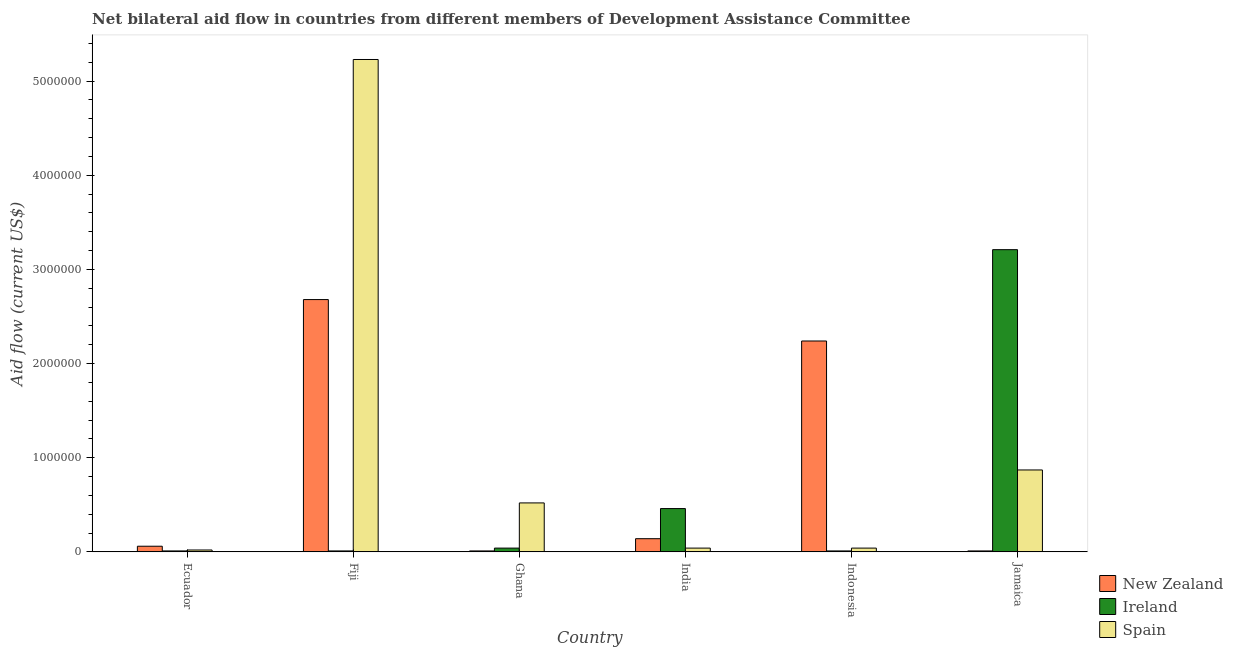How many different coloured bars are there?
Provide a short and direct response. 3. How many bars are there on the 3rd tick from the right?
Provide a succinct answer. 3. What is the label of the 3rd group of bars from the left?
Your response must be concise. Ghana. In how many cases, is the number of bars for a given country not equal to the number of legend labels?
Give a very brief answer. 0. What is the amount of aid provided by spain in Ghana?
Ensure brevity in your answer.  5.20e+05. Across all countries, what is the maximum amount of aid provided by ireland?
Provide a succinct answer. 3.21e+06. Across all countries, what is the minimum amount of aid provided by new zealand?
Your response must be concise. 10000. In which country was the amount of aid provided by spain maximum?
Your answer should be compact. Fiji. In which country was the amount of aid provided by ireland minimum?
Ensure brevity in your answer.  Ecuador. What is the total amount of aid provided by ireland in the graph?
Offer a terse response. 3.74e+06. What is the difference between the amount of aid provided by ireland in Fiji and that in India?
Provide a succinct answer. -4.50e+05. What is the difference between the amount of aid provided by ireland in Ecuador and the amount of aid provided by spain in Jamaica?
Provide a short and direct response. -8.60e+05. What is the average amount of aid provided by new zealand per country?
Give a very brief answer. 8.57e+05. What is the difference between the amount of aid provided by ireland and amount of aid provided by spain in Ghana?
Offer a very short reply. -4.80e+05. What is the ratio of the amount of aid provided by spain in Fiji to that in India?
Give a very brief answer. 130.75. What is the difference between the highest and the second highest amount of aid provided by ireland?
Give a very brief answer. 2.75e+06. What is the difference between the highest and the lowest amount of aid provided by ireland?
Your answer should be compact. 3.20e+06. In how many countries, is the amount of aid provided by spain greater than the average amount of aid provided by spain taken over all countries?
Ensure brevity in your answer.  1. Is the sum of the amount of aid provided by new zealand in Fiji and Ghana greater than the maximum amount of aid provided by spain across all countries?
Offer a very short reply. No. What does the 2nd bar from the left in Fiji represents?
Offer a terse response. Ireland. What does the 2nd bar from the right in India represents?
Your response must be concise. Ireland. How many bars are there?
Ensure brevity in your answer.  18. How many countries are there in the graph?
Your answer should be very brief. 6. What is the difference between two consecutive major ticks on the Y-axis?
Give a very brief answer. 1.00e+06. Are the values on the major ticks of Y-axis written in scientific E-notation?
Your answer should be very brief. No. Does the graph contain grids?
Give a very brief answer. No. How many legend labels are there?
Your response must be concise. 3. How are the legend labels stacked?
Ensure brevity in your answer.  Vertical. What is the title of the graph?
Offer a terse response. Net bilateral aid flow in countries from different members of Development Assistance Committee. What is the Aid flow (current US$) in New Zealand in Ecuador?
Offer a terse response. 6.00e+04. What is the Aid flow (current US$) in Spain in Ecuador?
Make the answer very short. 2.00e+04. What is the Aid flow (current US$) of New Zealand in Fiji?
Your response must be concise. 2.68e+06. What is the Aid flow (current US$) of Spain in Fiji?
Provide a short and direct response. 5.23e+06. What is the Aid flow (current US$) of New Zealand in Ghana?
Make the answer very short. 10000. What is the Aid flow (current US$) in Spain in Ghana?
Offer a terse response. 5.20e+05. What is the Aid flow (current US$) of Ireland in India?
Provide a succinct answer. 4.60e+05. What is the Aid flow (current US$) of Spain in India?
Give a very brief answer. 4.00e+04. What is the Aid flow (current US$) of New Zealand in Indonesia?
Give a very brief answer. 2.24e+06. What is the Aid flow (current US$) of Ireland in Indonesia?
Provide a succinct answer. 10000. What is the Aid flow (current US$) of Ireland in Jamaica?
Offer a terse response. 3.21e+06. What is the Aid flow (current US$) in Spain in Jamaica?
Your answer should be very brief. 8.70e+05. Across all countries, what is the maximum Aid flow (current US$) of New Zealand?
Keep it short and to the point. 2.68e+06. Across all countries, what is the maximum Aid flow (current US$) of Ireland?
Give a very brief answer. 3.21e+06. Across all countries, what is the maximum Aid flow (current US$) in Spain?
Your response must be concise. 5.23e+06. What is the total Aid flow (current US$) of New Zealand in the graph?
Make the answer very short. 5.14e+06. What is the total Aid flow (current US$) in Ireland in the graph?
Offer a terse response. 3.74e+06. What is the total Aid flow (current US$) in Spain in the graph?
Offer a terse response. 6.72e+06. What is the difference between the Aid flow (current US$) of New Zealand in Ecuador and that in Fiji?
Your response must be concise. -2.62e+06. What is the difference between the Aid flow (current US$) of Ireland in Ecuador and that in Fiji?
Keep it short and to the point. 0. What is the difference between the Aid flow (current US$) of Spain in Ecuador and that in Fiji?
Your response must be concise. -5.21e+06. What is the difference between the Aid flow (current US$) in Ireland in Ecuador and that in Ghana?
Your answer should be very brief. -3.00e+04. What is the difference between the Aid flow (current US$) in Spain in Ecuador and that in Ghana?
Your response must be concise. -5.00e+05. What is the difference between the Aid flow (current US$) in Ireland in Ecuador and that in India?
Ensure brevity in your answer.  -4.50e+05. What is the difference between the Aid flow (current US$) in New Zealand in Ecuador and that in Indonesia?
Your answer should be very brief. -2.18e+06. What is the difference between the Aid flow (current US$) of Spain in Ecuador and that in Indonesia?
Your answer should be compact. -2.00e+04. What is the difference between the Aid flow (current US$) of New Zealand in Ecuador and that in Jamaica?
Your response must be concise. 5.00e+04. What is the difference between the Aid flow (current US$) in Ireland in Ecuador and that in Jamaica?
Your answer should be very brief. -3.20e+06. What is the difference between the Aid flow (current US$) in Spain in Ecuador and that in Jamaica?
Provide a short and direct response. -8.50e+05. What is the difference between the Aid flow (current US$) of New Zealand in Fiji and that in Ghana?
Provide a short and direct response. 2.67e+06. What is the difference between the Aid flow (current US$) of Ireland in Fiji and that in Ghana?
Keep it short and to the point. -3.00e+04. What is the difference between the Aid flow (current US$) in Spain in Fiji and that in Ghana?
Your answer should be compact. 4.71e+06. What is the difference between the Aid flow (current US$) of New Zealand in Fiji and that in India?
Make the answer very short. 2.54e+06. What is the difference between the Aid flow (current US$) in Ireland in Fiji and that in India?
Offer a terse response. -4.50e+05. What is the difference between the Aid flow (current US$) of Spain in Fiji and that in India?
Your answer should be very brief. 5.19e+06. What is the difference between the Aid flow (current US$) in New Zealand in Fiji and that in Indonesia?
Provide a short and direct response. 4.40e+05. What is the difference between the Aid flow (current US$) in Ireland in Fiji and that in Indonesia?
Your answer should be very brief. 0. What is the difference between the Aid flow (current US$) of Spain in Fiji and that in Indonesia?
Make the answer very short. 5.19e+06. What is the difference between the Aid flow (current US$) of New Zealand in Fiji and that in Jamaica?
Offer a terse response. 2.67e+06. What is the difference between the Aid flow (current US$) in Ireland in Fiji and that in Jamaica?
Ensure brevity in your answer.  -3.20e+06. What is the difference between the Aid flow (current US$) of Spain in Fiji and that in Jamaica?
Keep it short and to the point. 4.36e+06. What is the difference between the Aid flow (current US$) of Ireland in Ghana and that in India?
Your response must be concise. -4.20e+05. What is the difference between the Aid flow (current US$) in Spain in Ghana and that in India?
Make the answer very short. 4.80e+05. What is the difference between the Aid flow (current US$) in New Zealand in Ghana and that in Indonesia?
Offer a terse response. -2.23e+06. What is the difference between the Aid flow (current US$) in Ireland in Ghana and that in Indonesia?
Your answer should be compact. 3.00e+04. What is the difference between the Aid flow (current US$) in New Zealand in Ghana and that in Jamaica?
Offer a terse response. 0. What is the difference between the Aid flow (current US$) of Ireland in Ghana and that in Jamaica?
Ensure brevity in your answer.  -3.17e+06. What is the difference between the Aid flow (current US$) in Spain in Ghana and that in Jamaica?
Provide a succinct answer. -3.50e+05. What is the difference between the Aid flow (current US$) in New Zealand in India and that in Indonesia?
Provide a succinct answer. -2.10e+06. What is the difference between the Aid flow (current US$) in New Zealand in India and that in Jamaica?
Keep it short and to the point. 1.30e+05. What is the difference between the Aid flow (current US$) in Ireland in India and that in Jamaica?
Make the answer very short. -2.75e+06. What is the difference between the Aid flow (current US$) in Spain in India and that in Jamaica?
Keep it short and to the point. -8.30e+05. What is the difference between the Aid flow (current US$) in New Zealand in Indonesia and that in Jamaica?
Your answer should be very brief. 2.23e+06. What is the difference between the Aid flow (current US$) in Ireland in Indonesia and that in Jamaica?
Your response must be concise. -3.20e+06. What is the difference between the Aid flow (current US$) in Spain in Indonesia and that in Jamaica?
Offer a very short reply. -8.30e+05. What is the difference between the Aid flow (current US$) in New Zealand in Ecuador and the Aid flow (current US$) in Spain in Fiji?
Offer a terse response. -5.17e+06. What is the difference between the Aid flow (current US$) in Ireland in Ecuador and the Aid flow (current US$) in Spain in Fiji?
Give a very brief answer. -5.22e+06. What is the difference between the Aid flow (current US$) of New Zealand in Ecuador and the Aid flow (current US$) of Spain in Ghana?
Provide a succinct answer. -4.60e+05. What is the difference between the Aid flow (current US$) in Ireland in Ecuador and the Aid flow (current US$) in Spain in Ghana?
Give a very brief answer. -5.10e+05. What is the difference between the Aid flow (current US$) in New Zealand in Ecuador and the Aid flow (current US$) in Ireland in India?
Give a very brief answer. -4.00e+05. What is the difference between the Aid flow (current US$) in New Zealand in Ecuador and the Aid flow (current US$) in Spain in India?
Your answer should be compact. 2.00e+04. What is the difference between the Aid flow (current US$) of New Zealand in Ecuador and the Aid flow (current US$) of Spain in Indonesia?
Your answer should be compact. 2.00e+04. What is the difference between the Aid flow (current US$) of New Zealand in Ecuador and the Aid flow (current US$) of Ireland in Jamaica?
Your answer should be compact. -3.15e+06. What is the difference between the Aid flow (current US$) in New Zealand in Ecuador and the Aid flow (current US$) in Spain in Jamaica?
Make the answer very short. -8.10e+05. What is the difference between the Aid flow (current US$) of Ireland in Ecuador and the Aid flow (current US$) of Spain in Jamaica?
Give a very brief answer. -8.60e+05. What is the difference between the Aid flow (current US$) of New Zealand in Fiji and the Aid flow (current US$) of Ireland in Ghana?
Offer a terse response. 2.64e+06. What is the difference between the Aid flow (current US$) in New Zealand in Fiji and the Aid flow (current US$) in Spain in Ghana?
Provide a short and direct response. 2.16e+06. What is the difference between the Aid flow (current US$) of Ireland in Fiji and the Aid flow (current US$) of Spain in Ghana?
Offer a very short reply. -5.10e+05. What is the difference between the Aid flow (current US$) of New Zealand in Fiji and the Aid flow (current US$) of Ireland in India?
Keep it short and to the point. 2.22e+06. What is the difference between the Aid flow (current US$) of New Zealand in Fiji and the Aid flow (current US$) of Spain in India?
Your answer should be compact. 2.64e+06. What is the difference between the Aid flow (current US$) of Ireland in Fiji and the Aid flow (current US$) of Spain in India?
Your response must be concise. -3.00e+04. What is the difference between the Aid flow (current US$) in New Zealand in Fiji and the Aid flow (current US$) in Ireland in Indonesia?
Give a very brief answer. 2.67e+06. What is the difference between the Aid flow (current US$) of New Zealand in Fiji and the Aid flow (current US$) of Spain in Indonesia?
Provide a succinct answer. 2.64e+06. What is the difference between the Aid flow (current US$) in New Zealand in Fiji and the Aid flow (current US$) in Ireland in Jamaica?
Your response must be concise. -5.30e+05. What is the difference between the Aid flow (current US$) in New Zealand in Fiji and the Aid flow (current US$) in Spain in Jamaica?
Offer a very short reply. 1.81e+06. What is the difference between the Aid flow (current US$) in Ireland in Fiji and the Aid flow (current US$) in Spain in Jamaica?
Your response must be concise. -8.60e+05. What is the difference between the Aid flow (current US$) of New Zealand in Ghana and the Aid flow (current US$) of Ireland in India?
Offer a terse response. -4.50e+05. What is the difference between the Aid flow (current US$) of New Zealand in Ghana and the Aid flow (current US$) of Ireland in Indonesia?
Provide a short and direct response. 0. What is the difference between the Aid flow (current US$) of Ireland in Ghana and the Aid flow (current US$) of Spain in Indonesia?
Provide a short and direct response. 0. What is the difference between the Aid flow (current US$) of New Zealand in Ghana and the Aid flow (current US$) of Ireland in Jamaica?
Provide a short and direct response. -3.20e+06. What is the difference between the Aid flow (current US$) in New Zealand in Ghana and the Aid flow (current US$) in Spain in Jamaica?
Provide a short and direct response. -8.60e+05. What is the difference between the Aid flow (current US$) of Ireland in Ghana and the Aid flow (current US$) of Spain in Jamaica?
Provide a succinct answer. -8.30e+05. What is the difference between the Aid flow (current US$) of Ireland in India and the Aid flow (current US$) of Spain in Indonesia?
Ensure brevity in your answer.  4.20e+05. What is the difference between the Aid flow (current US$) in New Zealand in India and the Aid flow (current US$) in Ireland in Jamaica?
Your answer should be compact. -3.07e+06. What is the difference between the Aid flow (current US$) in New Zealand in India and the Aid flow (current US$) in Spain in Jamaica?
Offer a very short reply. -7.30e+05. What is the difference between the Aid flow (current US$) in Ireland in India and the Aid flow (current US$) in Spain in Jamaica?
Offer a very short reply. -4.10e+05. What is the difference between the Aid flow (current US$) of New Zealand in Indonesia and the Aid flow (current US$) of Ireland in Jamaica?
Make the answer very short. -9.70e+05. What is the difference between the Aid flow (current US$) of New Zealand in Indonesia and the Aid flow (current US$) of Spain in Jamaica?
Your response must be concise. 1.37e+06. What is the difference between the Aid flow (current US$) in Ireland in Indonesia and the Aid flow (current US$) in Spain in Jamaica?
Make the answer very short. -8.60e+05. What is the average Aid flow (current US$) of New Zealand per country?
Offer a very short reply. 8.57e+05. What is the average Aid flow (current US$) in Ireland per country?
Offer a terse response. 6.23e+05. What is the average Aid flow (current US$) of Spain per country?
Your response must be concise. 1.12e+06. What is the difference between the Aid flow (current US$) of New Zealand and Aid flow (current US$) of Ireland in Ecuador?
Offer a very short reply. 5.00e+04. What is the difference between the Aid flow (current US$) in New Zealand and Aid flow (current US$) in Spain in Ecuador?
Your response must be concise. 4.00e+04. What is the difference between the Aid flow (current US$) in Ireland and Aid flow (current US$) in Spain in Ecuador?
Offer a terse response. -10000. What is the difference between the Aid flow (current US$) in New Zealand and Aid flow (current US$) in Ireland in Fiji?
Your answer should be very brief. 2.67e+06. What is the difference between the Aid flow (current US$) in New Zealand and Aid flow (current US$) in Spain in Fiji?
Your answer should be compact. -2.55e+06. What is the difference between the Aid flow (current US$) of Ireland and Aid flow (current US$) of Spain in Fiji?
Give a very brief answer. -5.22e+06. What is the difference between the Aid flow (current US$) of New Zealand and Aid flow (current US$) of Spain in Ghana?
Give a very brief answer. -5.10e+05. What is the difference between the Aid flow (current US$) of Ireland and Aid flow (current US$) of Spain in Ghana?
Make the answer very short. -4.80e+05. What is the difference between the Aid flow (current US$) in New Zealand and Aid flow (current US$) in Ireland in India?
Provide a short and direct response. -3.20e+05. What is the difference between the Aid flow (current US$) of Ireland and Aid flow (current US$) of Spain in India?
Offer a very short reply. 4.20e+05. What is the difference between the Aid flow (current US$) of New Zealand and Aid flow (current US$) of Ireland in Indonesia?
Your answer should be compact. 2.23e+06. What is the difference between the Aid flow (current US$) in New Zealand and Aid flow (current US$) in Spain in Indonesia?
Your answer should be compact. 2.20e+06. What is the difference between the Aid flow (current US$) in New Zealand and Aid flow (current US$) in Ireland in Jamaica?
Your answer should be compact. -3.20e+06. What is the difference between the Aid flow (current US$) of New Zealand and Aid flow (current US$) of Spain in Jamaica?
Your response must be concise. -8.60e+05. What is the difference between the Aid flow (current US$) in Ireland and Aid flow (current US$) in Spain in Jamaica?
Offer a very short reply. 2.34e+06. What is the ratio of the Aid flow (current US$) of New Zealand in Ecuador to that in Fiji?
Make the answer very short. 0.02. What is the ratio of the Aid flow (current US$) of Ireland in Ecuador to that in Fiji?
Provide a short and direct response. 1. What is the ratio of the Aid flow (current US$) in Spain in Ecuador to that in Fiji?
Keep it short and to the point. 0. What is the ratio of the Aid flow (current US$) of Ireland in Ecuador to that in Ghana?
Your response must be concise. 0.25. What is the ratio of the Aid flow (current US$) of Spain in Ecuador to that in Ghana?
Your answer should be very brief. 0.04. What is the ratio of the Aid flow (current US$) of New Zealand in Ecuador to that in India?
Provide a short and direct response. 0.43. What is the ratio of the Aid flow (current US$) of Ireland in Ecuador to that in India?
Provide a short and direct response. 0.02. What is the ratio of the Aid flow (current US$) of Spain in Ecuador to that in India?
Give a very brief answer. 0.5. What is the ratio of the Aid flow (current US$) in New Zealand in Ecuador to that in Indonesia?
Offer a terse response. 0.03. What is the ratio of the Aid flow (current US$) in Ireland in Ecuador to that in Indonesia?
Your answer should be compact. 1. What is the ratio of the Aid flow (current US$) in New Zealand in Ecuador to that in Jamaica?
Provide a succinct answer. 6. What is the ratio of the Aid flow (current US$) in Ireland in Ecuador to that in Jamaica?
Your answer should be compact. 0. What is the ratio of the Aid flow (current US$) of Spain in Ecuador to that in Jamaica?
Give a very brief answer. 0.02. What is the ratio of the Aid flow (current US$) in New Zealand in Fiji to that in Ghana?
Keep it short and to the point. 268. What is the ratio of the Aid flow (current US$) in Ireland in Fiji to that in Ghana?
Provide a succinct answer. 0.25. What is the ratio of the Aid flow (current US$) of Spain in Fiji to that in Ghana?
Your answer should be very brief. 10.06. What is the ratio of the Aid flow (current US$) of New Zealand in Fiji to that in India?
Provide a short and direct response. 19.14. What is the ratio of the Aid flow (current US$) in Ireland in Fiji to that in India?
Your answer should be very brief. 0.02. What is the ratio of the Aid flow (current US$) of Spain in Fiji to that in India?
Provide a short and direct response. 130.75. What is the ratio of the Aid flow (current US$) in New Zealand in Fiji to that in Indonesia?
Provide a succinct answer. 1.2. What is the ratio of the Aid flow (current US$) in Ireland in Fiji to that in Indonesia?
Provide a short and direct response. 1. What is the ratio of the Aid flow (current US$) of Spain in Fiji to that in Indonesia?
Offer a very short reply. 130.75. What is the ratio of the Aid flow (current US$) in New Zealand in Fiji to that in Jamaica?
Ensure brevity in your answer.  268. What is the ratio of the Aid flow (current US$) in Ireland in Fiji to that in Jamaica?
Provide a succinct answer. 0. What is the ratio of the Aid flow (current US$) in Spain in Fiji to that in Jamaica?
Offer a very short reply. 6.01. What is the ratio of the Aid flow (current US$) of New Zealand in Ghana to that in India?
Your response must be concise. 0.07. What is the ratio of the Aid flow (current US$) in Ireland in Ghana to that in India?
Give a very brief answer. 0.09. What is the ratio of the Aid flow (current US$) of Spain in Ghana to that in India?
Make the answer very short. 13. What is the ratio of the Aid flow (current US$) in New Zealand in Ghana to that in Indonesia?
Your answer should be very brief. 0. What is the ratio of the Aid flow (current US$) of New Zealand in Ghana to that in Jamaica?
Give a very brief answer. 1. What is the ratio of the Aid flow (current US$) in Ireland in Ghana to that in Jamaica?
Your response must be concise. 0.01. What is the ratio of the Aid flow (current US$) of Spain in Ghana to that in Jamaica?
Offer a very short reply. 0.6. What is the ratio of the Aid flow (current US$) of New Zealand in India to that in Indonesia?
Ensure brevity in your answer.  0.06. What is the ratio of the Aid flow (current US$) of Ireland in India to that in Indonesia?
Give a very brief answer. 46. What is the ratio of the Aid flow (current US$) in Ireland in India to that in Jamaica?
Ensure brevity in your answer.  0.14. What is the ratio of the Aid flow (current US$) in Spain in India to that in Jamaica?
Give a very brief answer. 0.05. What is the ratio of the Aid flow (current US$) in New Zealand in Indonesia to that in Jamaica?
Provide a succinct answer. 224. What is the ratio of the Aid flow (current US$) of Ireland in Indonesia to that in Jamaica?
Offer a very short reply. 0. What is the ratio of the Aid flow (current US$) of Spain in Indonesia to that in Jamaica?
Ensure brevity in your answer.  0.05. What is the difference between the highest and the second highest Aid flow (current US$) in Ireland?
Offer a terse response. 2.75e+06. What is the difference between the highest and the second highest Aid flow (current US$) of Spain?
Offer a very short reply. 4.36e+06. What is the difference between the highest and the lowest Aid flow (current US$) in New Zealand?
Offer a very short reply. 2.67e+06. What is the difference between the highest and the lowest Aid flow (current US$) in Ireland?
Keep it short and to the point. 3.20e+06. What is the difference between the highest and the lowest Aid flow (current US$) in Spain?
Make the answer very short. 5.21e+06. 